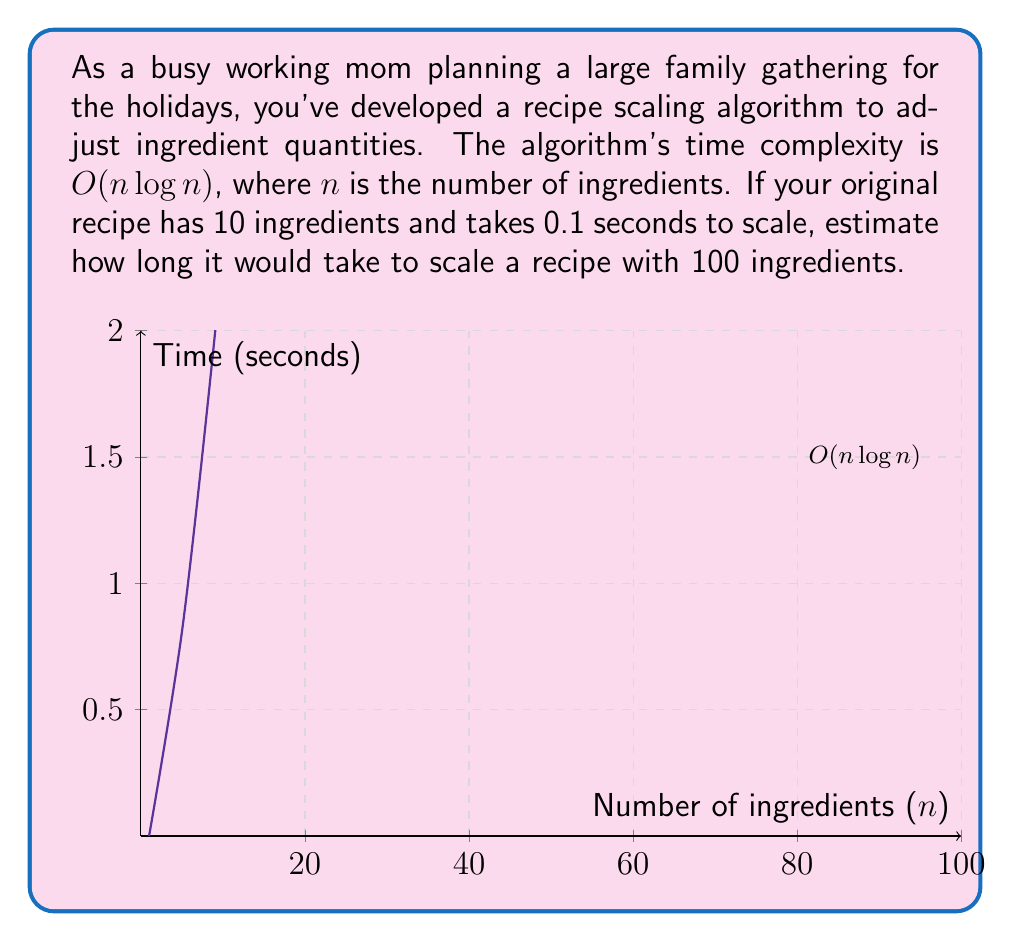Show me your answer to this math problem. Let's approach this step-by-step:

1) The time complexity is $O(n \log n)$, which means the time taken is proportional to $n \log n$.

2) For the original recipe:
   $n_1 = 10$ ingredients
   $t_1 = 0.1$ seconds

3) For the new recipe:
   $n_2 = 100$ ingredients
   $t_2 = ?$ (what we need to find)

4) We can set up a proportion:

   $$\frac{t_1}{n_1 \log n_1} = \frac{t_2}{n_2 \log n_2}$$

5) Substituting the known values:

   $$\frac{0.1}{10 \log 10} = \frac{t_2}{100 \log 100}$$

6) Solving for $t_2$:

   $$t_2 = \frac{0.1 \cdot 100 \log 100}{10 \log 10}$$

7) Simplify:
   
   $$t_2 = \frac{10 \log 100}{\log 10} = 10 \cdot \frac{\log 100}{\log 10} = 10 \cdot 2 = 20$$

Therefore, it would take approximately 20 seconds to scale the recipe with 100 ingredients.
Answer: 20 seconds 